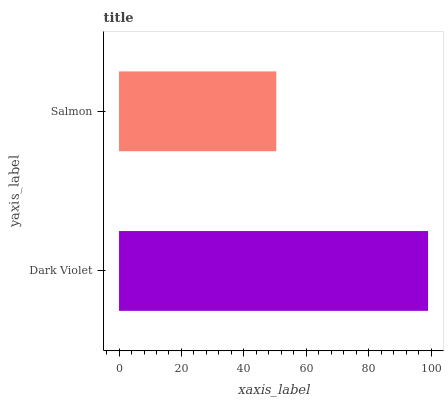Is Salmon the minimum?
Answer yes or no. Yes. Is Dark Violet the maximum?
Answer yes or no. Yes. Is Salmon the maximum?
Answer yes or no. No. Is Dark Violet greater than Salmon?
Answer yes or no. Yes. Is Salmon less than Dark Violet?
Answer yes or no. Yes. Is Salmon greater than Dark Violet?
Answer yes or no. No. Is Dark Violet less than Salmon?
Answer yes or no. No. Is Dark Violet the high median?
Answer yes or no. Yes. Is Salmon the low median?
Answer yes or no. Yes. Is Salmon the high median?
Answer yes or no. No. Is Dark Violet the low median?
Answer yes or no. No. 